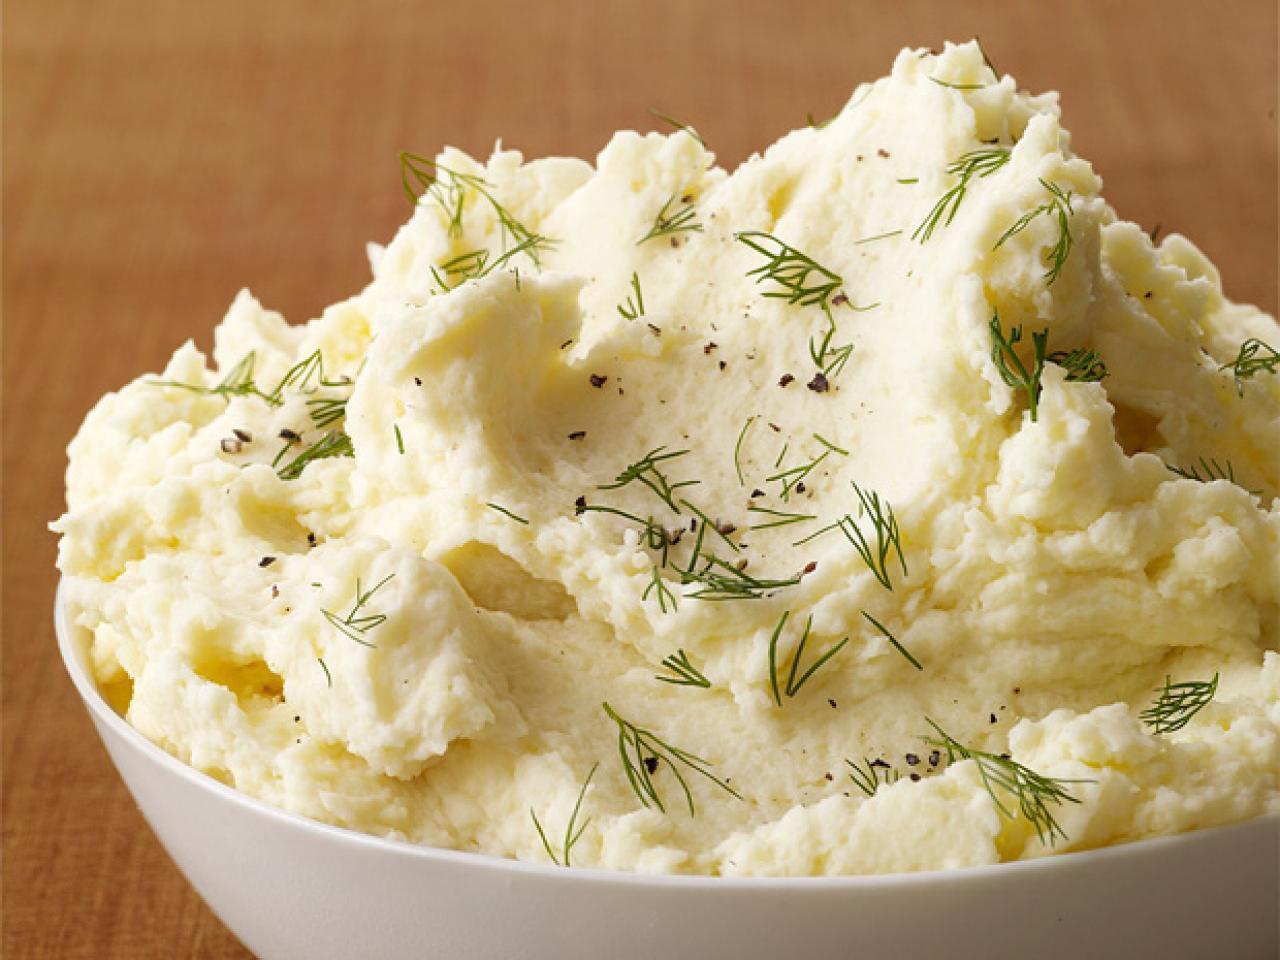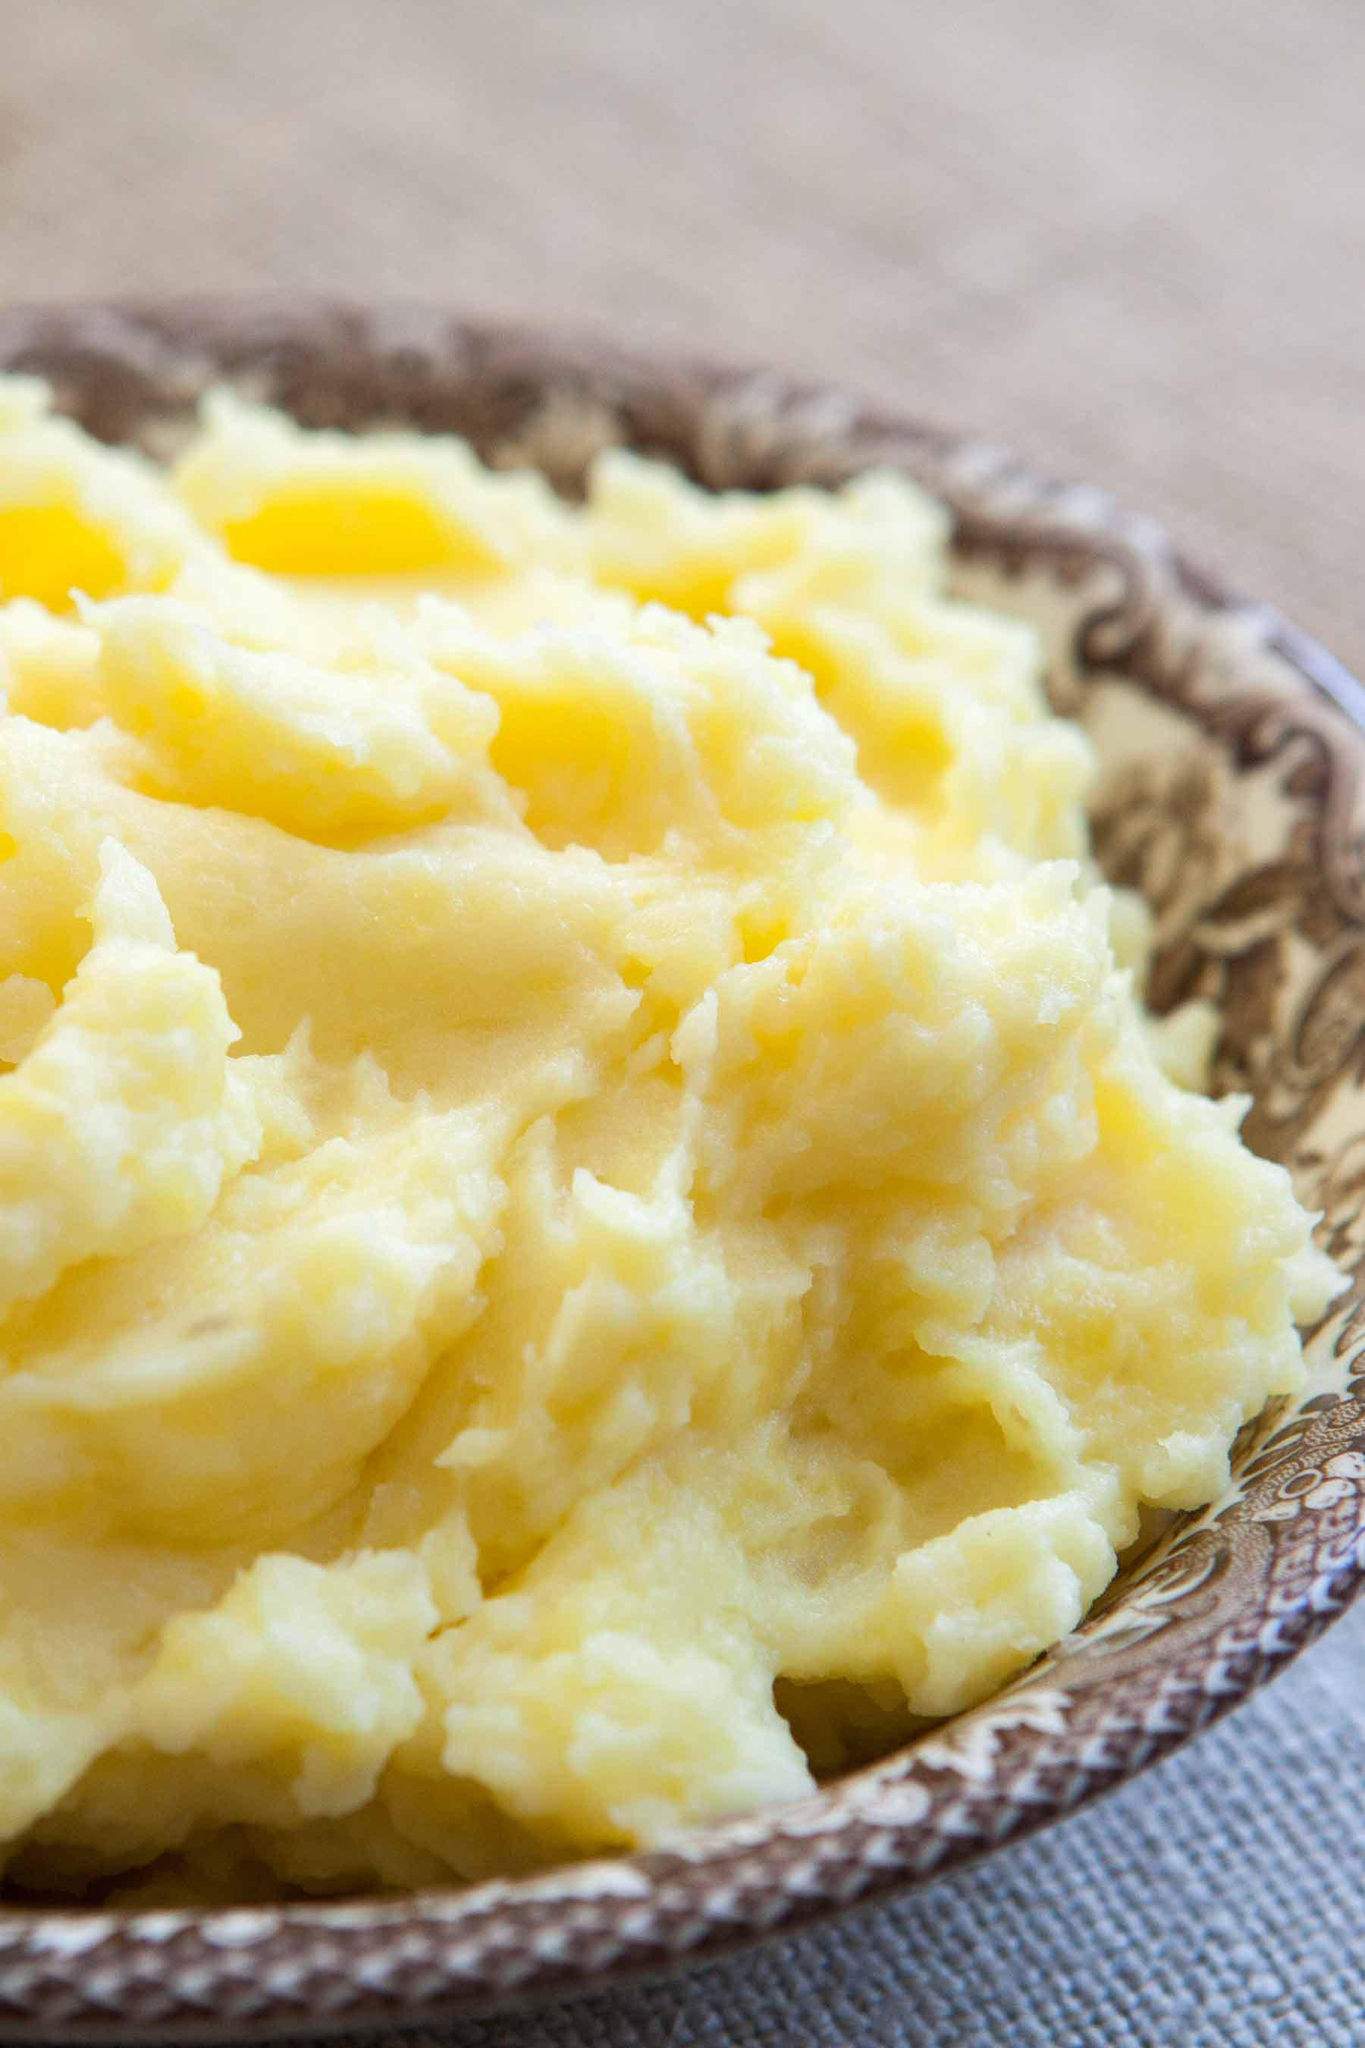The first image is the image on the left, the second image is the image on the right. For the images displayed, is the sentence "herbs are sprinkled over the mashed potato" factually correct? Answer yes or no. Yes. 